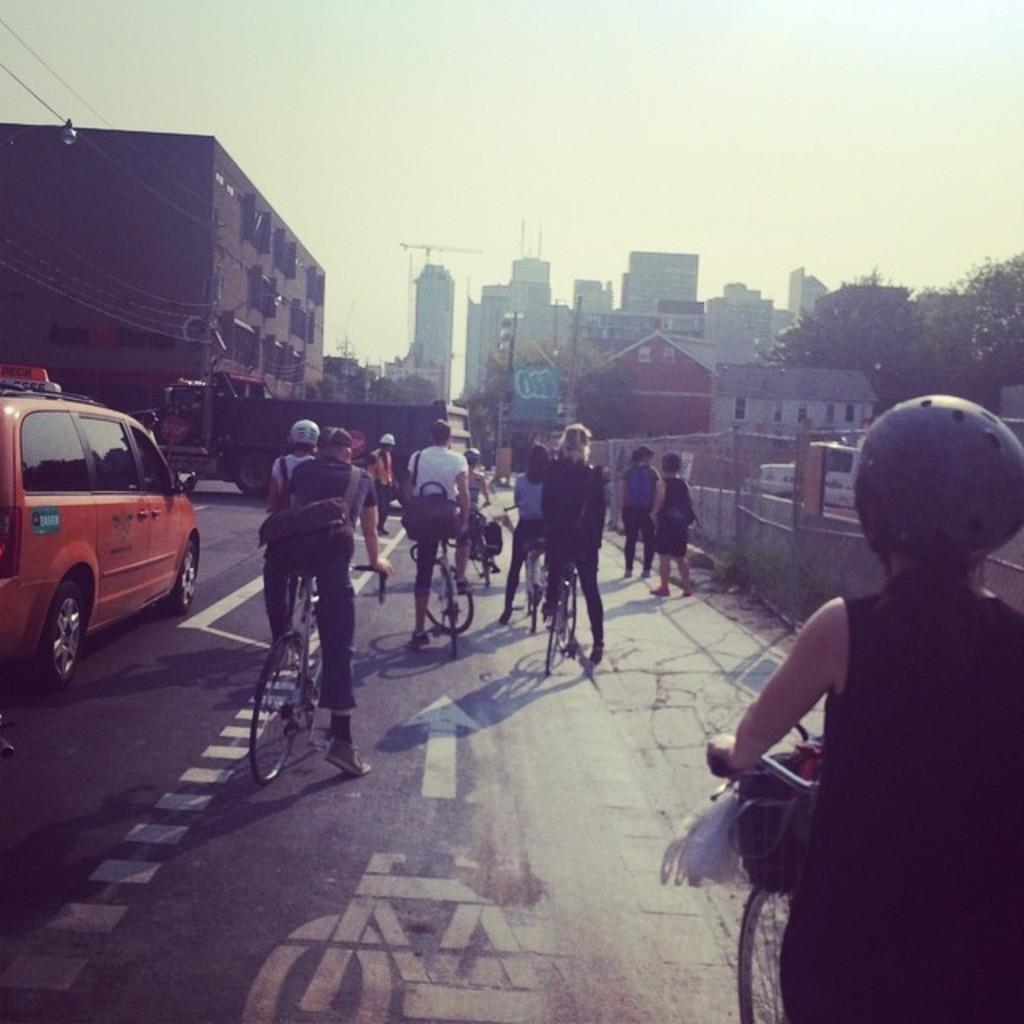What are the people in the image doing? The people in the image are riding bicycles. What else can be seen in the image besides the people on bicycles? There is a car and a building in the image. What type of horn can be heard coming from the ghost in the image? There is no ghost present in the image, so it's not possible to determine what, if any, horn might be heard. 